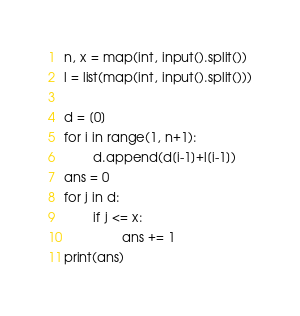<code> <loc_0><loc_0><loc_500><loc_500><_Python_>n, x = map(int, input().split())
l = list(map(int, input().split()))

d = [0]
for i in range(1, n+1):
        d.append(d[i-1]+l[i-1])
ans = 0
for j in d:
        if j <= x:
                ans += 1
print(ans)</code> 